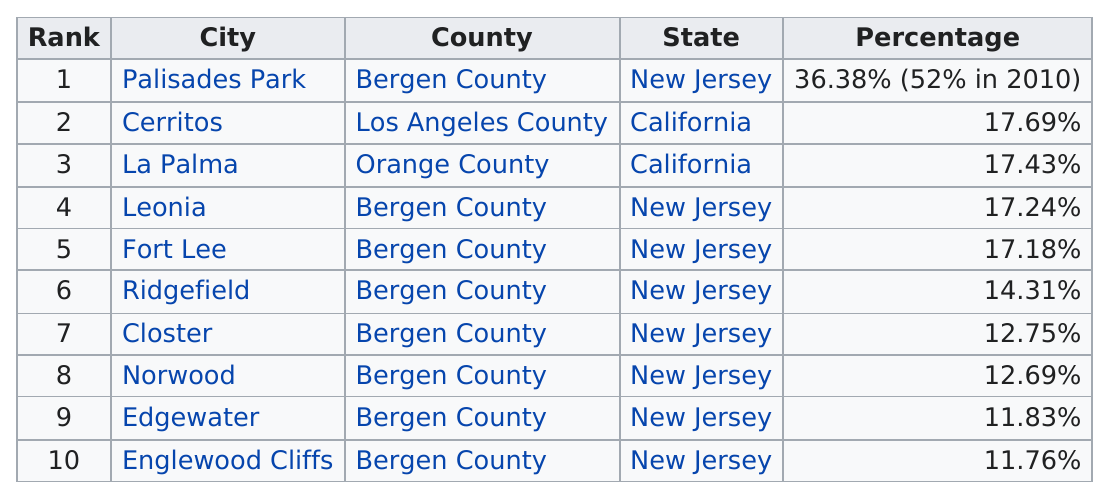Specify some key components in this picture. According to recent data, the city with the highest percentage of Korean-American population is Palisades Park. There are three cities in New Jersey where the Korean population is greater than 15%. Five municipalities have a population with an above 15% Korean American percentage of their overall population. Palisades Park is ranked first on the list. Bergen County has the most representation. 